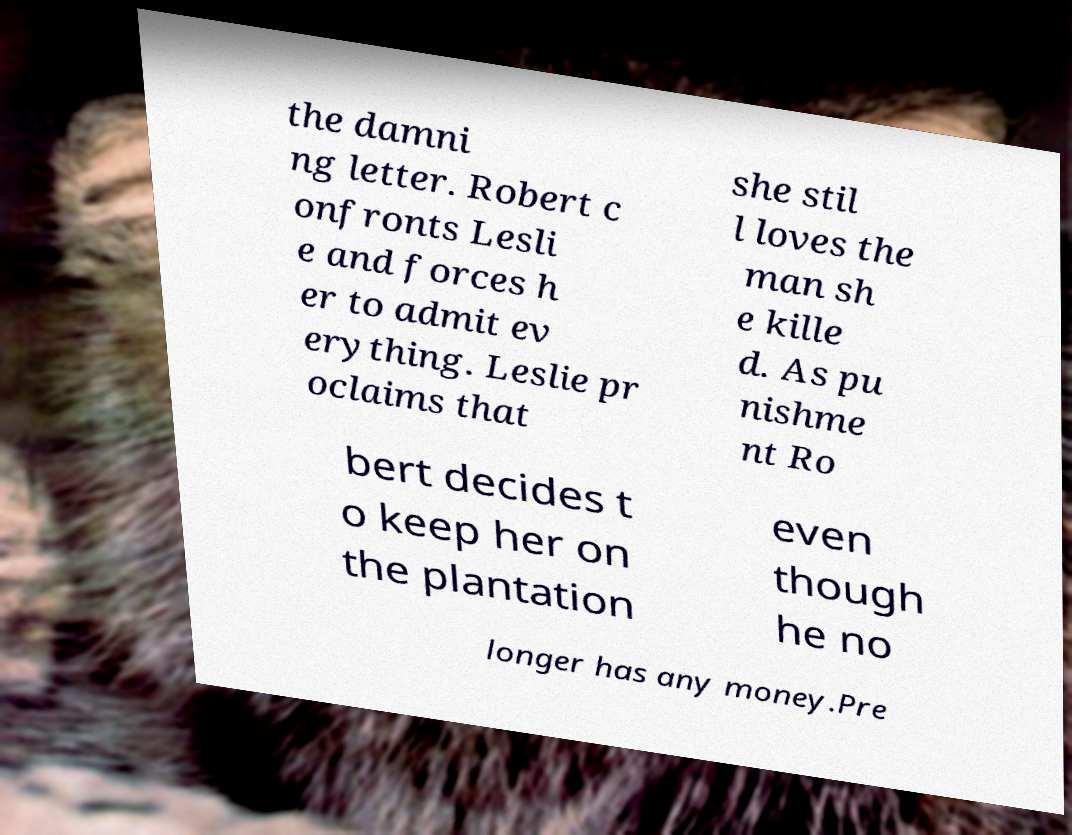There's text embedded in this image that I need extracted. Can you transcribe it verbatim? the damni ng letter. Robert c onfronts Lesli e and forces h er to admit ev erything. Leslie pr oclaims that she stil l loves the man sh e kille d. As pu nishme nt Ro bert decides t o keep her on the plantation even though he no longer has any money.Pre 